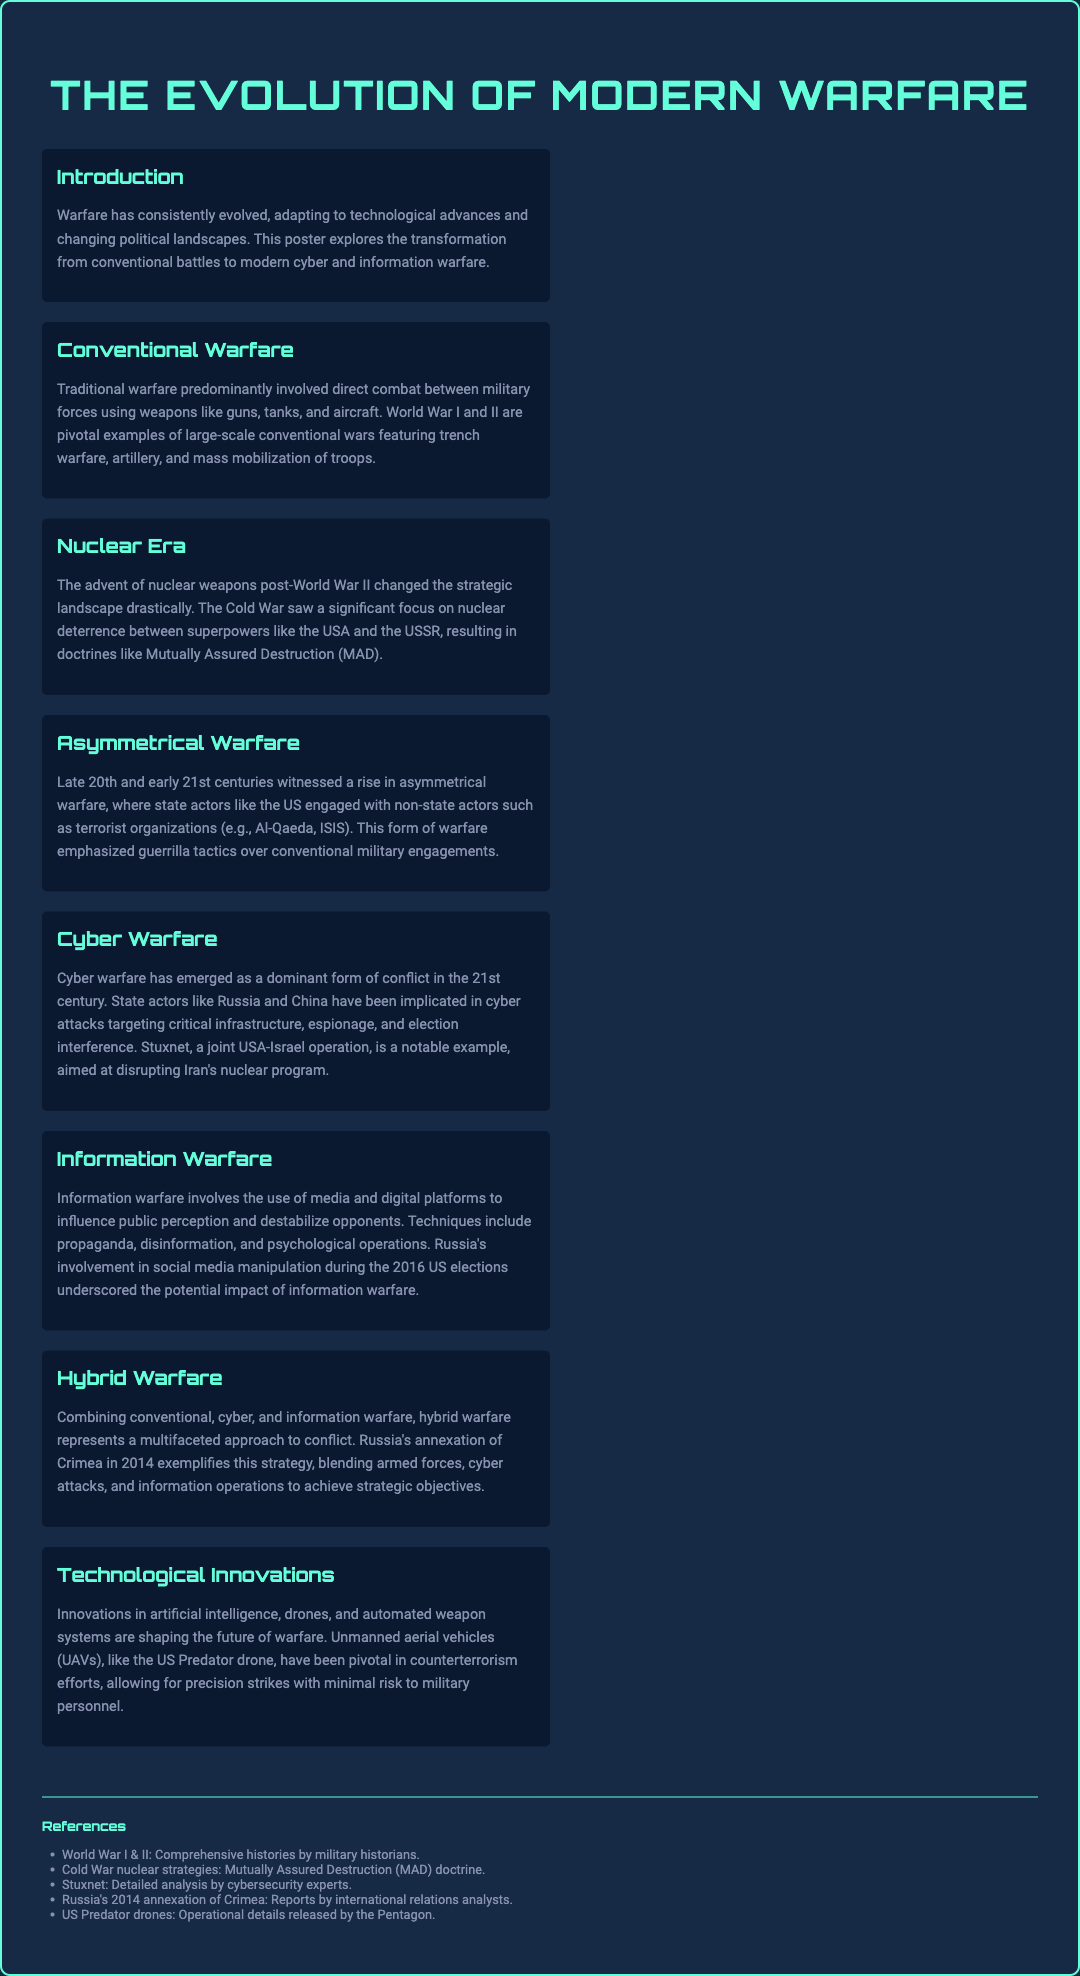what is the title of the poster? The title is presented prominently at the top of the poster.
Answer: The Evolution of Modern Warfare which war is mentioned as a pivotal example of conventional warfare? The document refers to significant conflicts that exhibited traditional military engagements.
Answer: World War I and II what is the strategic doctrine that emerged during the Nuclear Era? This term describes the deterrence strategy that developed as a response to nuclear armament.
Answer: Mutually Assured Destruction (MAD) who are alleged to be involved in cyber warfare according to the document? The text names specific state actors that have engaged in recent cyber conflicts.
Answer: Russia and China what type of warfare combines conventional, cyber, and information tactics? This term defines a comprehensive approach to modern military strategies blending different warfare types.
Answer: Hybrid Warfare which technology is highlighted for its role in counterterrorism efforts? The document discusses a specific type of technology utilized to conduct military operations with reduced risk.
Answer: Unmanned aerial vehicles (UAVs) what year did Russia annex Crimea? This event is presented within the context of hybrid warfare strategies employed in modern conflicts.
Answer: 2014 which operation is noted for its intent to disrupt Iran's nuclear program? The document mentions a particular cyber operation that targeted Iran's nuclear capabilities.
Answer: Stuxnet 